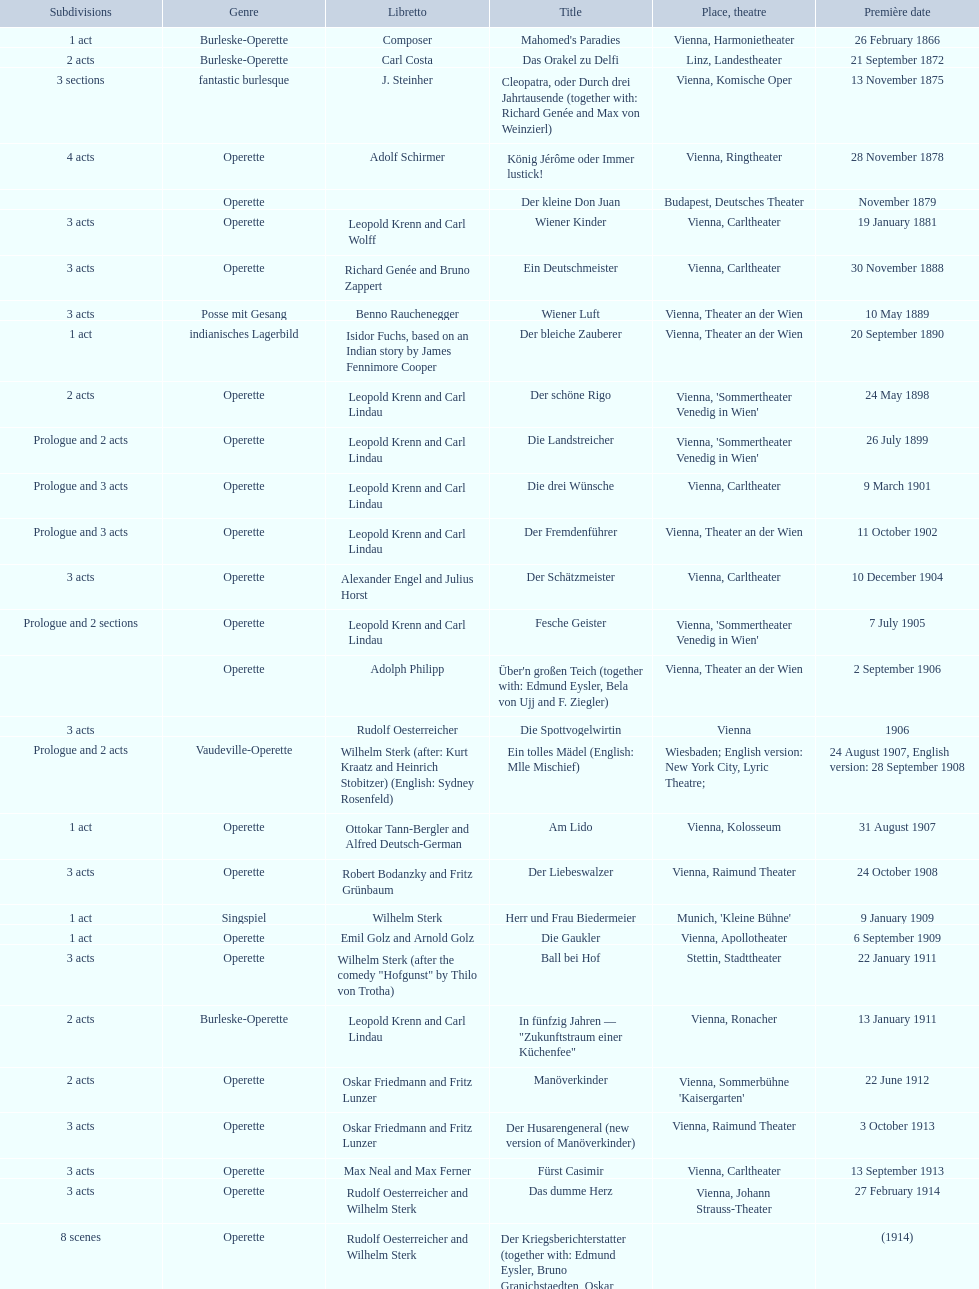In what year did he launch his final operetta? 1930. 